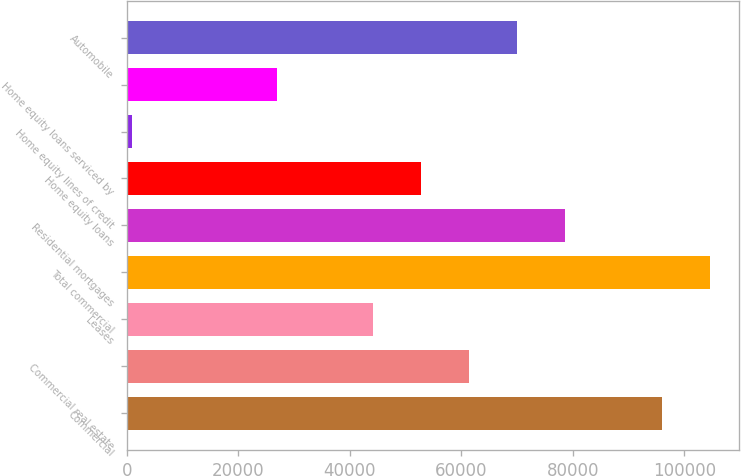<chart> <loc_0><loc_0><loc_500><loc_500><bar_chart><fcel>Commercial<fcel>Commercial real estate<fcel>Leases<fcel>Total commercial<fcel>Residential mortgages<fcel>Home equity loans<fcel>Home equity lines of credit<fcel>Home equity loans serviced by<fcel>Automobile<nl><fcel>95879.2<fcel>61354.4<fcel>44092<fcel>104510<fcel>78616.8<fcel>52723.2<fcel>936<fcel>26829.6<fcel>69985.6<nl></chart> 